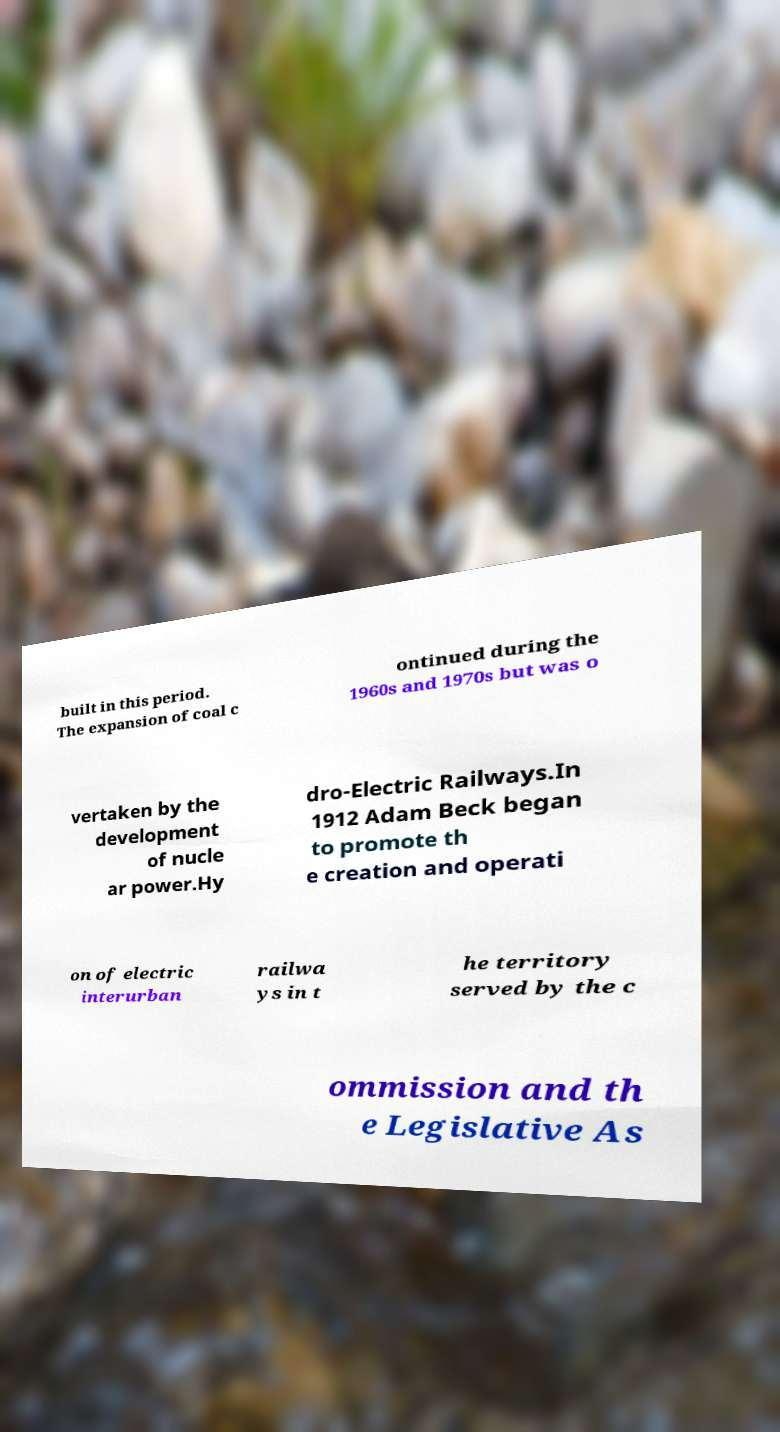Please read and relay the text visible in this image. What does it say? built in this period. The expansion of coal c ontinued during the 1960s and 1970s but was o vertaken by the development of nucle ar power.Hy dro-Electric Railways.In 1912 Adam Beck began to promote th e creation and operati on of electric interurban railwa ys in t he territory served by the c ommission and th e Legislative As 